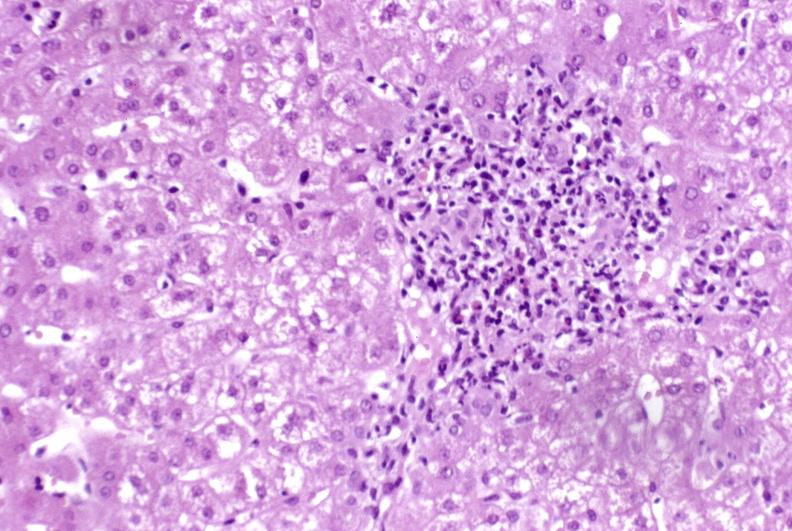s ectopic pancreas present?
Answer the question using a single word or phrase. No 